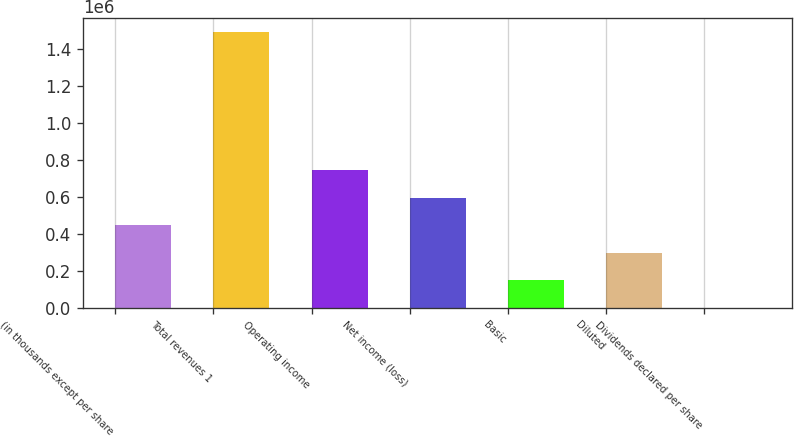Convert chart to OTSL. <chart><loc_0><loc_0><loc_500><loc_500><bar_chart><fcel>(in thousands except per share<fcel>Total revenues 1<fcel>Operating income<fcel>Net income (loss)<fcel>Basic<fcel>Diluted<fcel>Dividends declared per share<nl><fcel>447329<fcel>1.4911e+06<fcel>745548<fcel>596438<fcel>149110<fcel>298219<fcel>0.15<nl></chart> 